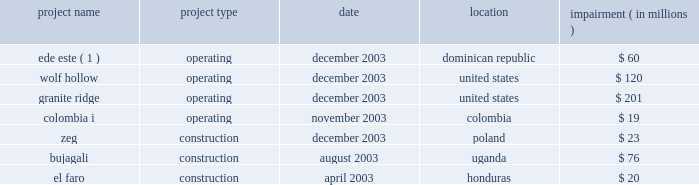We cannot assure you that the gener restructuring will be completed or that the terms thereof will not be changed materially .
In addition , gener is in the process of restructuring the debt of its subsidiaries , termoandes s.a .
( 2018 2018termoandes 2019 2019 ) and interandes , s.a .
( 2018 2018interandes 2019 2019 ) , and expects that the maturities of these obligations will be extended .
Under-performing businesses during 2003 we sold or discontinued under-performing businesses and construction projects that did not meet our investment criteria or did not provide reasonable opportunities to restructure .
It is anticipated that there will be less ongoing activity related to write-offs of development or construction projects and impairment charges in the future .
The businesses , which were affected in 2003 , are listed below .
Impairment project name project type date location ( in millions ) .
( 1 ) see note 4 2014discontinued operations .
Improving credit quality our de-leveraging efforts reduced parent level debt by $ 1.2 billion in 2003 ( including the secured equity-linked loan previously issued by aes new york funding l.l.c. ) .
We refinanced and paid down near-term maturities by $ 3.5 billion and enhanced our year-end liquidity to over $ 1 billion .
Our average debt maturity was extended from 2009 to 2012 .
At the subsidiary level we continue to pursue limited recourse financing to reduce parent credit risk .
These factors resulted in an overall reduced cost of capital , improved credit statistics and expanded access to credit at both aes and our subsidiaries .
Liquidity at the aes parent level is an important factor for the rating agencies in determining whether the company 2019s credit quality should improve .
Currency and political risk tend to be biggest variables to sustaining predictable cash flow .
The nature of our large contractual and concession-based cash flow from these businesses serves to mitigate these variables .
In 2003 , over 81% ( 81 % ) of cash distributions to the parent company were from u.s .
Large utilities and worldwide contract generation .
On february 4 , 2004 , we called for redemption of $ 155049000 aggregate principal amount of outstanding 8% ( 8 % ) senior notes due 2008 , which represents the entire outstanding principal amount of the 8% ( 8 % ) senior notes due 2008 , and $ 34174000 aggregate principal amount of outstanding 10% ( 10 % ) secured senior notes due 2005 .
The 8% ( 8 % ) senior notes due 2008 and the 10% ( 10 % ) secured senior notes due 2005 were redeemed on march 8 , 2004 at a redemption price equal to 100% ( 100 % ) of the principal amount plus accrued and unpaid interest to the redemption date .
The mandatory redemption of the 10% ( 10 % ) secured senior notes due 2005 was being made with a portion of our 2018 2018adjusted free cash flow 2019 2019 ( as defined in the indenture pursuant to which the notes were issued ) for the fiscal year ended december 31 , 2003 as required by the indenture and was made on a pro rata basis .
On february 13 , 2004 we issued $ 500 million of unsecured senior notes .
The unsecured senior notes mature on march 1 , 2014 and are callable at our option at any time at a redemption price equal to 100% ( 100 % ) of the principal amount of the unsecured senior notes plus a make-whole premium .
The unsecured senior notes were issued at a price of 98.288% ( 98.288 % ) and pay interest semi-annually at an annual .
What was the total impairment relating to us assets? 
Computations: ((120 + 201) * 1000000)
Answer: 321000000.0. We cannot assure you that the gener restructuring will be completed or that the terms thereof will not be changed materially .
In addition , gener is in the process of restructuring the debt of its subsidiaries , termoandes s.a .
( 2018 2018termoandes 2019 2019 ) and interandes , s.a .
( 2018 2018interandes 2019 2019 ) , and expects that the maturities of these obligations will be extended .
Under-performing businesses during 2003 we sold or discontinued under-performing businesses and construction projects that did not meet our investment criteria or did not provide reasonable opportunities to restructure .
It is anticipated that there will be less ongoing activity related to write-offs of development or construction projects and impairment charges in the future .
The businesses , which were affected in 2003 , are listed below .
Impairment project name project type date location ( in millions ) .
( 1 ) see note 4 2014discontinued operations .
Improving credit quality our de-leveraging efforts reduced parent level debt by $ 1.2 billion in 2003 ( including the secured equity-linked loan previously issued by aes new york funding l.l.c. ) .
We refinanced and paid down near-term maturities by $ 3.5 billion and enhanced our year-end liquidity to over $ 1 billion .
Our average debt maturity was extended from 2009 to 2012 .
At the subsidiary level we continue to pursue limited recourse financing to reduce parent credit risk .
These factors resulted in an overall reduced cost of capital , improved credit statistics and expanded access to credit at both aes and our subsidiaries .
Liquidity at the aes parent level is an important factor for the rating agencies in determining whether the company 2019s credit quality should improve .
Currency and political risk tend to be biggest variables to sustaining predictable cash flow .
The nature of our large contractual and concession-based cash flow from these businesses serves to mitigate these variables .
In 2003 , over 81% ( 81 % ) of cash distributions to the parent company were from u.s .
Large utilities and worldwide contract generation .
On february 4 , 2004 , we called for redemption of $ 155049000 aggregate principal amount of outstanding 8% ( 8 % ) senior notes due 2008 , which represents the entire outstanding principal amount of the 8% ( 8 % ) senior notes due 2008 , and $ 34174000 aggregate principal amount of outstanding 10% ( 10 % ) secured senior notes due 2005 .
The 8% ( 8 % ) senior notes due 2008 and the 10% ( 10 % ) secured senior notes due 2005 were redeemed on march 8 , 2004 at a redemption price equal to 100% ( 100 % ) of the principal amount plus accrued and unpaid interest to the redemption date .
The mandatory redemption of the 10% ( 10 % ) secured senior notes due 2005 was being made with a portion of our 2018 2018adjusted free cash flow 2019 2019 ( as defined in the indenture pursuant to which the notes were issued ) for the fiscal year ended december 31 , 2003 as required by the indenture and was made on a pro rata basis .
On february 13 , 2004 we issued $ 500 million of unsecured senior notes .
The unsecured senior notes mature on march 1 , 2014 and are callable at our option at any time at a redemption price equal to 100% ( 100 % ) of the principal amount of the unsecured senior notes plus a make-whole premium .
The unsecured senior notes were issued at a price of 98.288% ( 98.288 % ) and pay interest semi-annually at an annual .
How many years was the average debt maturity extended for? 
Computations: (2012 - 2009)
Answer: 3.0. 